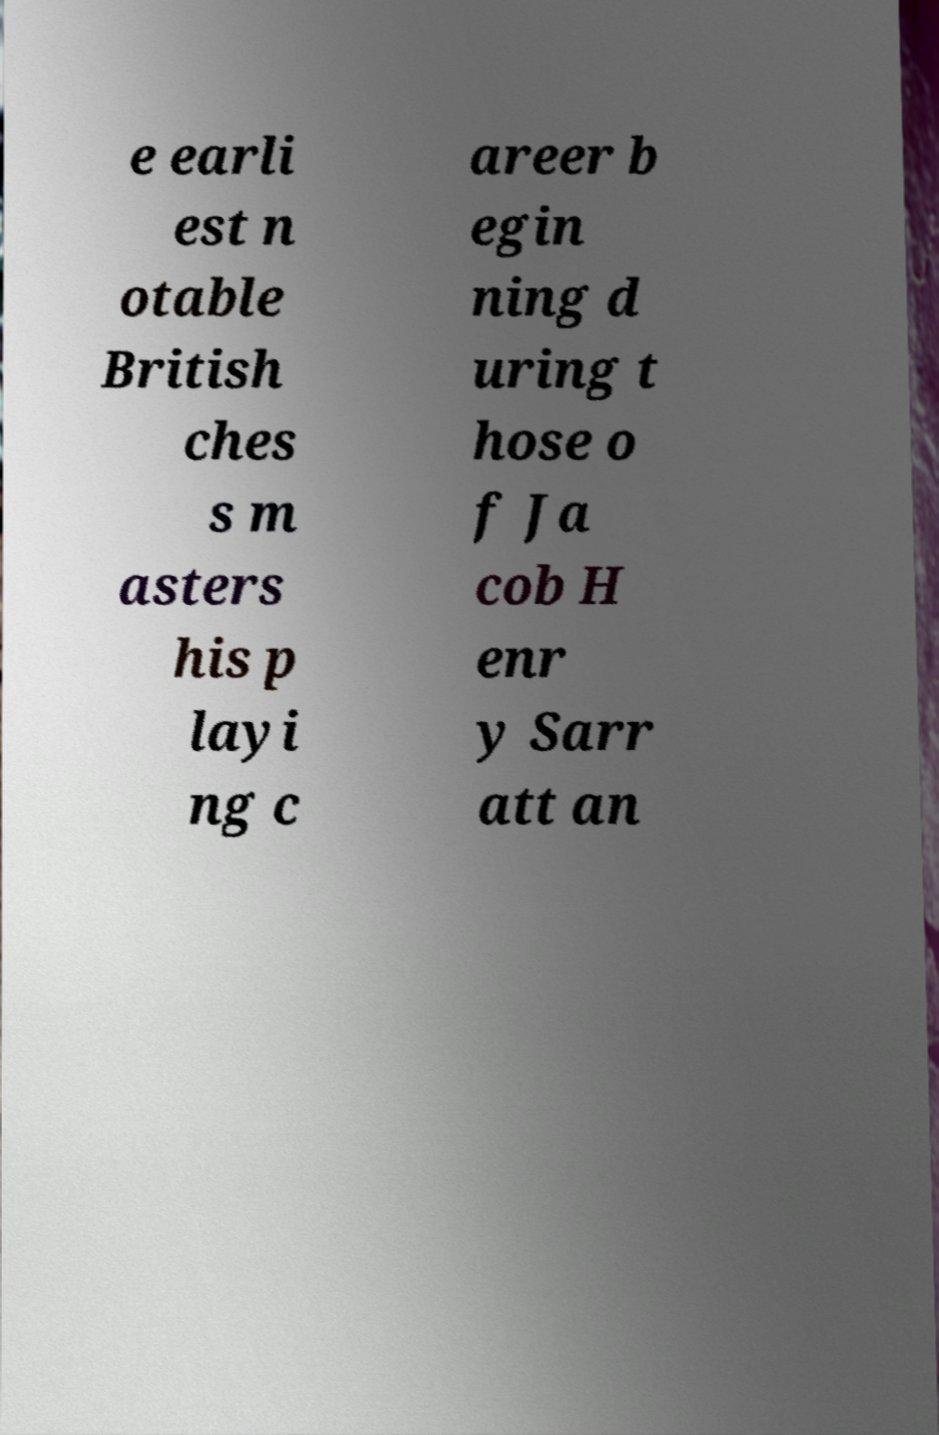Please read and relay the text visible in this image. What does it say? e earli est n otable British ches s m asters his p layi ng c areer b egin ning d uring t hose o f Ja cob H enr y Sarr att an 